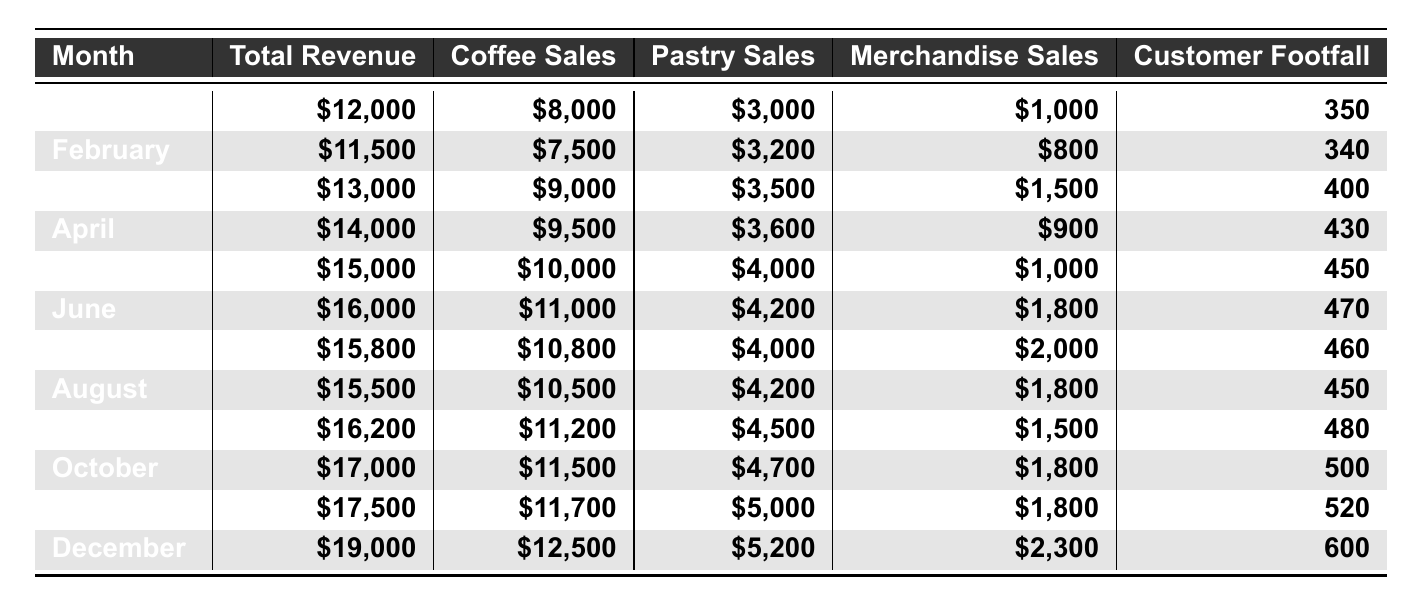What was the total revenue in December? The table indicates the total revenue for December is listed directly as $19,000.
Answer: $19,000 Which month had the highest coffee sales? Looking through the coffee sales column, June shows the highest value of $11,000.
Answer: June How much merchandise was sold in October? In the table, the merchandise sales for October are explicitly stated as $1,800.
Answer: $1,800 What was the increase in total revenue from January to May? The total revenue in January is $12,000, and in May it is $15,000. The increase is calculated by subtracting January's revenue from May's: $15,000 - $12,000 = $3,000.
Answer: $3,000 How many customers visited the coffee shop in November? The number of customers for November is recorded in the table as 520.
Answer: 520 Calculate the average pastry sales per month from January to March. The total pastry sales from January to March are $3,000 + $3,200 + $3,500 = $9,700. There are 3 months, so the average is $9,700 / 3 ≈ $3,233.33.
Answer: $3,233.33 Did the coffee shop have more customer footfall in March or July? In March, the customer footfall is 400, while in July it is 460. Since 460 > 400, more customers visited in July.
Answer: July What is the total revenue for the first half of the year (January to June)? The revenues for January to June are $12,000 + $11,500 + $13,000 + $14,000 + $15,000 + $16,000 = $81,500.
Answer: $81,500 Which month had the largest increase in customer footfall compared to the previous month? By comparing customer footfall month over month, the largest increase is from November (520) to December (600), which is an increase of 80.
Answer: December Is the total revenue for the second half of the year greater than that for the first half? The total revenue from July to December is $15,800 + $15,500 + $16,200 + $17,000 + $17,500 + $19,000 = $100,000. The first half totals $81,500. Since $100,000 > $81,500, the statement is true.
Answer: Yes 